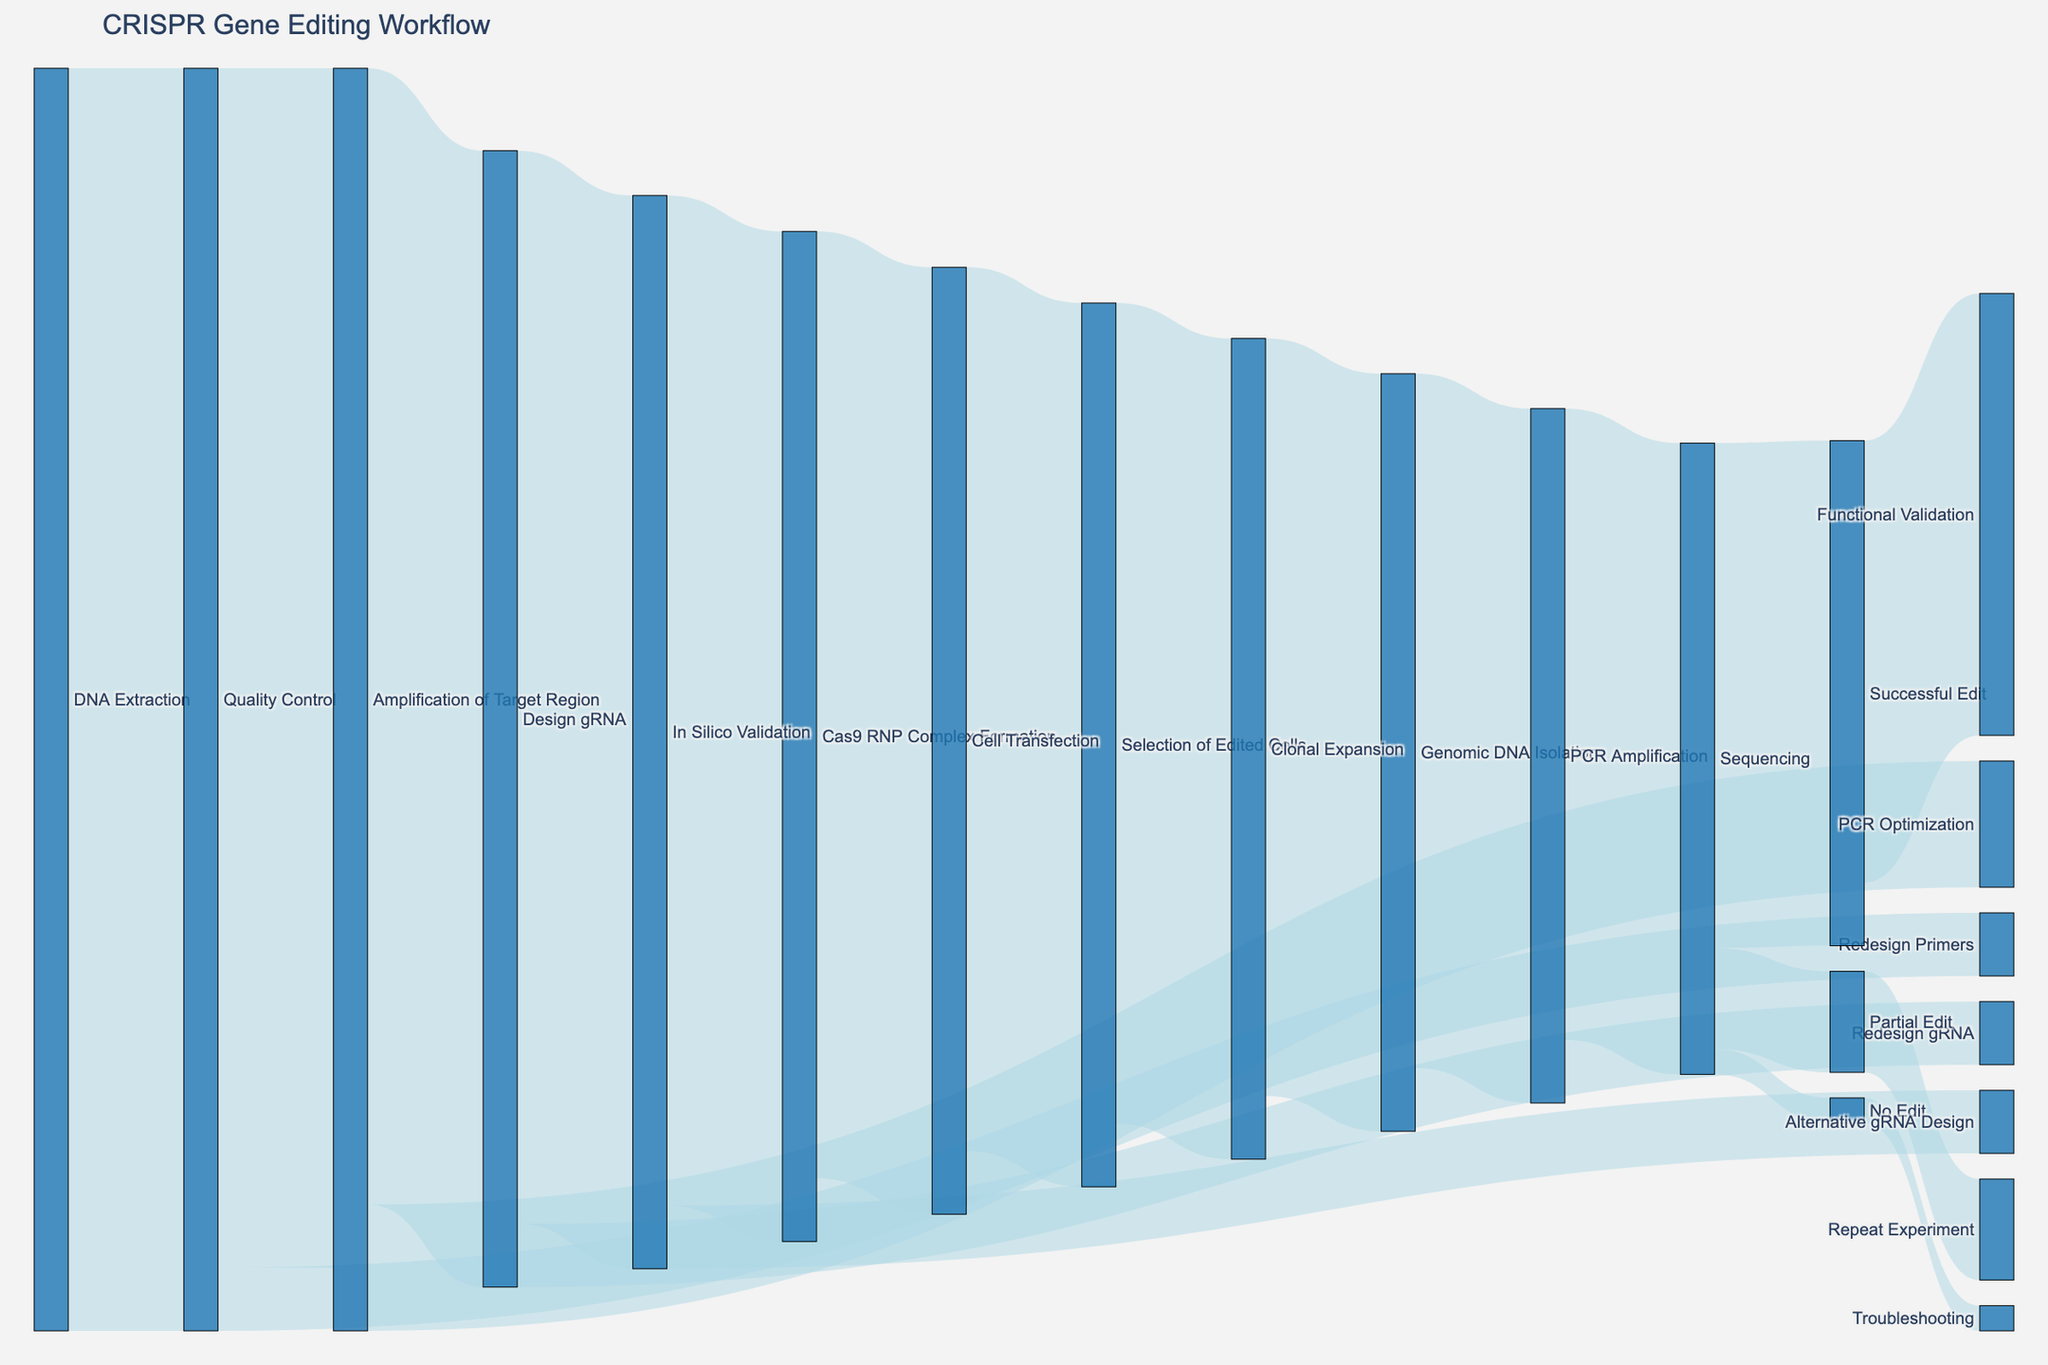what is the title of the figure? The title is displayed at the top of the figure. The title text is "CRISPR Gene Editing Workflow," indicating the overall subject of the Sankey Diagram.
Answer: CRISPR Gene Editing Workflow How many steps are involved in the workflow starting from "DNA Extraction" to "Functional Validation"? To count the steps, trace the path from "DNA Extraction" to "Functional Validation": DNA Extraction -> Quality Control -> Amplification of Target Region -> Design gRNA -> In Silico Validation -> Cas9 RNP Complex Formation -> Cell Transfection -> Selection of Edited Cells -> Clonal Expansion -> Genomic DNA Isolation -> PCR Amplification -> Sequencing -> Successful Edit -> Functional Validation. There are 14 steps.
Answer: 14 Which step has the highest loss in the workflow? To determine the highest loss, identify the step with the largest difference between input and output values. "Quality Control" starts with 100 and proceeds to 95, losing 5; "Design gRNA" goes from 90 to 85, losing 5. However, from "Sequencing" to "Successful Edit," it drops from 50 to 40, losing 10, which is the largest loss.
Answer: Sequencing What's the total number of cells involved from start to end in the "Amplification of Target Region" step? The input number of cells to "Amplification of Target Region" is 95. Two paths diverge: "Design gRNA" with 90 cells and "PCR Optimization" with 10 cells. Adding the values: 95 - (90 + 10) = -5, which indicates an error in counting. The correct understanding is the direct number of 95 involved.
Answer: 95 Compare the number of cells progressing from "In Silico Validation" to "Cas9 RNP Complex Formation" and those that go on to "Alternative gRNA Design." Which path sees more cells? "In Silico Validation" sends 80 cells to "Cas9 RNP Complex Formation" and 5 cells to "Alternative gRNA Design." Comparing the two: 80 > 5.
Answer: In Silico Validation to Cas9 RNP Complex Formation What percentage of cells undergo "Functional Validation" compared to those that end up in "Partial Edit"? "Functional Validation" receives 35 cells out of 50 from "Sequencing," while "Partial Edit" receives 8. To find the percentage: (35 / 50) * 100 = 70% for "Functional Validation" and (8 / 50) * 100 = 16% for "Partial Edit." Comparing them, 70% is higher than 16%.
Answer: 70% How many total paths are there that lead to "Troubleshooting"? Identify the paths connecting all nodes to "Troubleshooting." The only path leading to "Troubleshooting" is from "No Edit." Therefore, there is only 1 path.
Answer: 1 Do more cells get processed through "Genomic DNA Isolation" or "Clonal Expansion"? "Clonal Expansion" involves 65 cells and "Genomic DNA Isolation" has 60. Comparing the two: 65 > 60, so more cells are processed through "Clonal Expansion."
Answer: Clonal Expansion Is the number of cells undergoing "Redesign Primers" greater than those involved in "Alternative gRNA Design"? "Redesign Primers" involves 5 cells from "Quality Control." "Alternative gRNA Design" involves 5 cells from "In Silico Validation." Both paths involve the same number of cells.
Answer: equal 